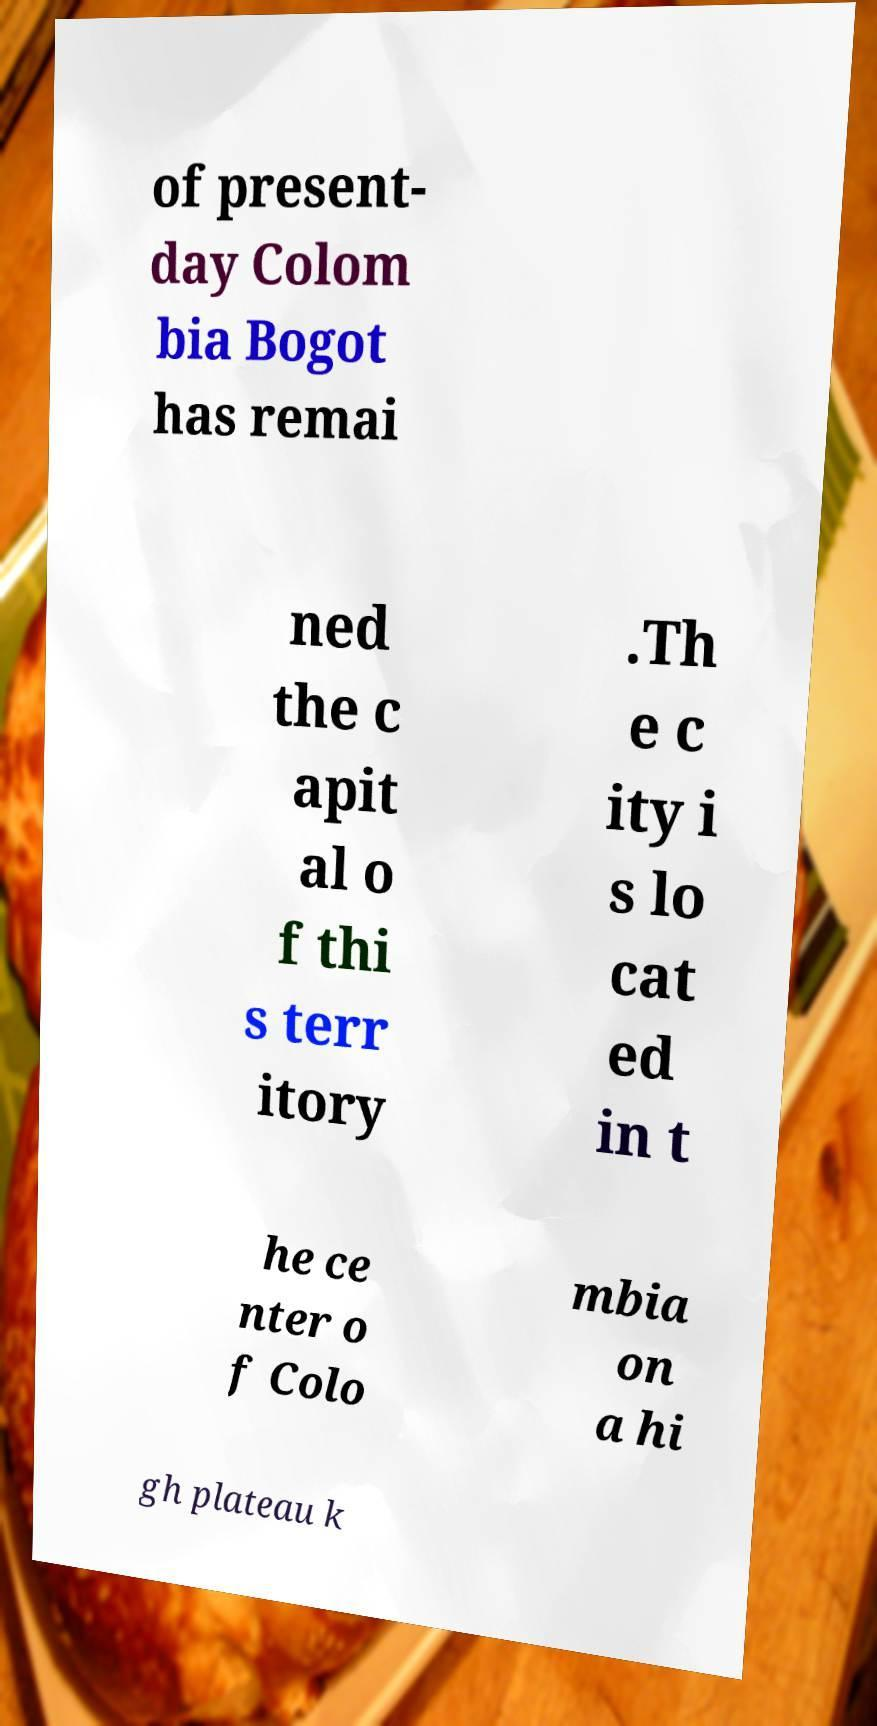Could you extract and type out the text from this image? of present- day Colom bia Bogot has remai ned the c apit al o f thi s terr itory .Th e c ity i s lo cat ed in t he ce nter o f Colo mbia on a hi gh plateau k 